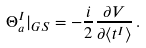<formula> <loc_0><loc_0><loc_500><loc_500>\Theta _ { a } ^ { I } | _ { G S } = - \frac { i } { 2 } \frac { \partial V } { \partial \langle t ^ { I } \rangle } \, .</formula> 